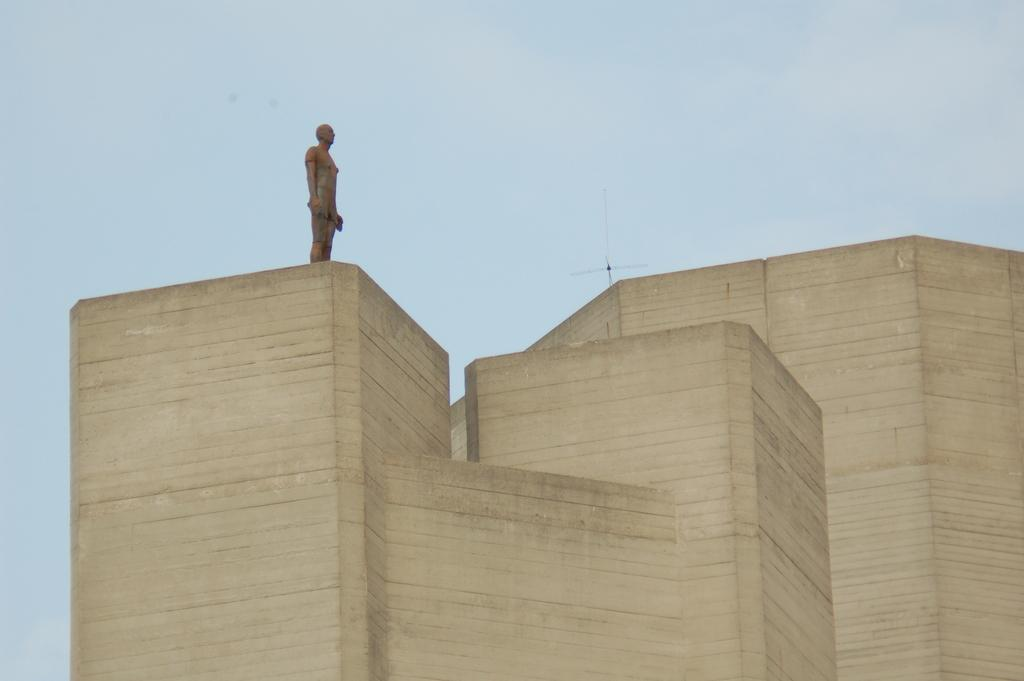What is the main subject of the image? The main subject of the image is an architecture. Can you describe any additional features on the architecture? Yes, there is a sculpture on the architecture. What type of flower is depicted in the writing on the architecture? There is no writing or flower present on the architecture in the image. 